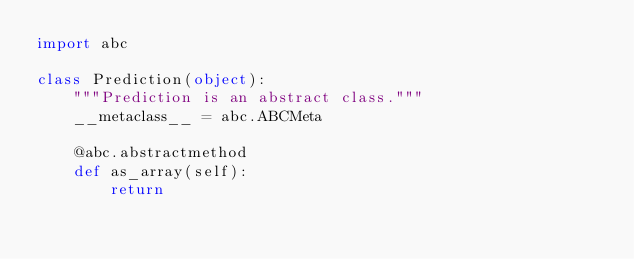Convert code to text. <code><loc_0><loc_0><loc_500><loc_500><_Python_>import abc

class Prediction(object):
    """Prediction is an abstract class."""
    __metaclass__ = abc.ABCMeta

    @abc.abstractmethod
    def as_array(self):
        return

</code> 